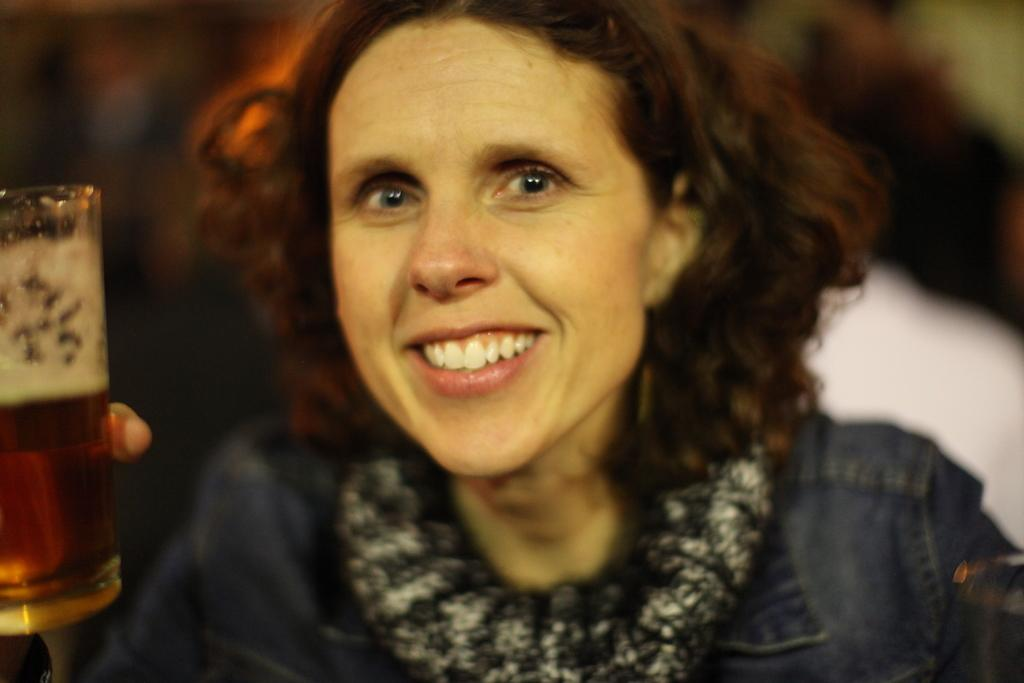Who is present in the image? There is a woman in the image. What is the woman's facial expression? The woman is smiling. What is the woman holding in her hand? The woman is holding a glass with her hand. What type of sheet is the woman using to cover the fly in the image? There is no sheet or fly present in the image. 